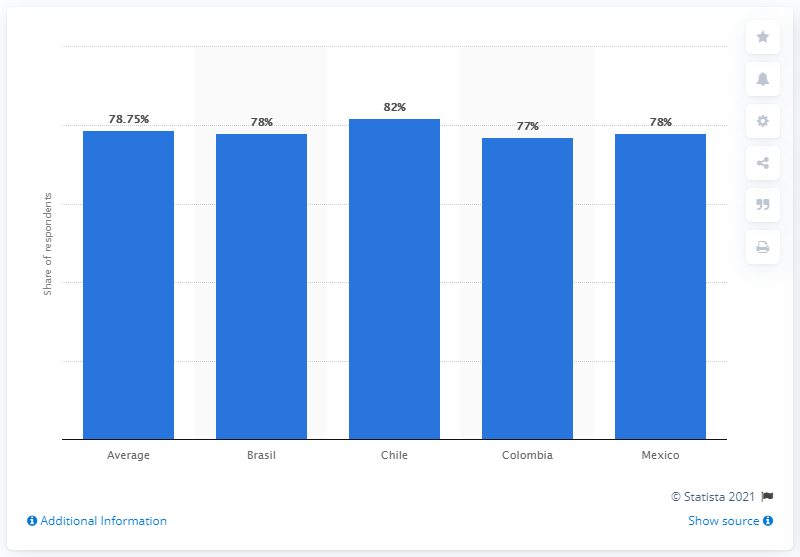Give some essential details in this illustration. In 2015, the average share of the reading population among the four countries was 78.75%. 